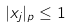<formula> <loc_0><loc_0><loc_500><loc_500>| x _ { j } | _ { p } \leq 1</formula> 